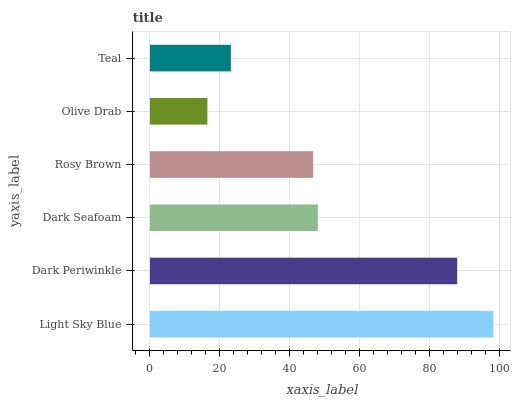Is Olive Drab the minimum?
Answer yes or no. Yes. Is Light Sky Blue the maximum?
Answer yes or no. Yes. Is Dark Periwinkle the minimum?
Answer yes or no. No. Is Dark Periwinkle the maximum?
Answer yes or no. No. Is Light Sky Blue greater than Dark Periwinkle?
Answer yes or no. Yes. Is Dark Periwinkle less than Light Sky Blue?
Answer yes or no. Yes. Is Dark Periwinkle greater than Light Sky Blue?
Answer yes or no. No. Is Light Sky Blue less than Dark Periwinkle?
Answer yes or no. No. Is Dark Seafoam the high median?
Answer yes or no. Yes. Is Rosy Brown the low median?
Answer yes or no. Yes. Is Teal the high median?
Answer yes or no. No. Is Light Sky Blue the low median?
Answer yes or no. No. 